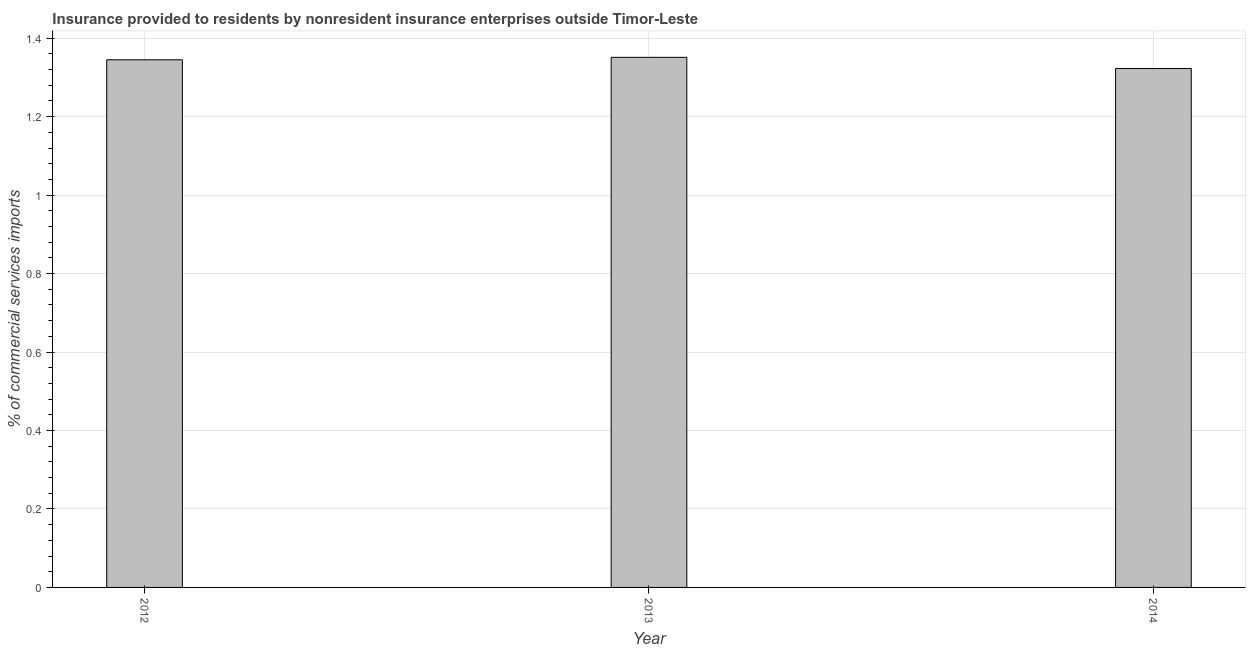Does the graph contain grids?
Offer a very short reply. Yes. What is the title of the graph?
Your answer should be very brief. Insurance provided to residents by nonresident insurance enterprises outside Timor-Leste. What is the label or title of the Y-axis?
Offer a terse response. % of commercial services imports. What is the insurance provided by non-residents in 2012?
Your answer should be very brief. 1.34. Across all years, what is the maximum insurance provided by non-residents?
Make the answer very short. 1.35. Across all years, what is the minimum insurance provided by non-residents?
Give a very brief answer. 1.32. What is the sum of the insurance provided by non-residents?
Ensure brevity in your answer.  4.02. What is the difference between the insurance provided by non-residents in 2013 and 2014?
Keep it short and to the point. 0.03. What is the average insurance provided by non-residents per year?
Your answer should be very brief. 1.34. What is the median insurance provided by non-residents?
Provide a succinct answer. 1.34. Do a majority of the years between 2014 and 2012 (inclusive) have insurance provided by non-residents greater than 1.36 %?
Your answer should be compact. Yes. What is the ratio of the insurance provided by non-residents in 2012 to that in 2013?
Ensure brevity in your answer.  0.99. Is the insurance provided by non-residents in 2012 less than that in 2014?
Keep it short and to the point. No. Is the difference between the insurance provided by non-residents in 2013 and 2014 greater than the difference between any two years?
Your response must be concise. Yes. What is the difference between the highest and the second highest insurance provided by non-residents?
Give a very brief answer. 0.01. How many bars are there?
Provide a succinct answer. 3. Are all the bars in the graph horizontal?
Provide a short and direct response. No. What is the difference between two consecutive major ticks on the Y-axis?
Offer a very short reply. 0.2. What is the % of commercial services imports of 2012?
Provide a succinct answer. 1.34. What is the % of commercial services imports in 2013?
Give a very brief answer. 1.35. What is the % of commercial services imports in 2014?
Provide a succinct answer. 1.32. What is the difference between the % of commercial services imports in 2012 and 2013?
Provide a succinct answer. -0.01. What is the difference between the % of commercial services imports in 2012 and 2014?
Offer a terse response. 0.02. What is the difference between the % of commercial services imports in 2013 and 2014?
Provide a short and direct response. 0.03. What is the ratio of the % of commercial services imports in 2012 to that in 2014?
Your response must be concise. 1.02. What is the ratio of the % of commercial services imports in 2013 to that in 2014?
Ensure brevity in your answer.  1.02. 